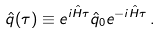<formula> <loc_0><loc_0><loc_500><loc_500>\hat { q } ( \tau ) \equiv e ^ { i \hat { H } \tau } \hat { q } _ { 0 } e ^ { - i \hat { H } \tau } \, .</formula> 